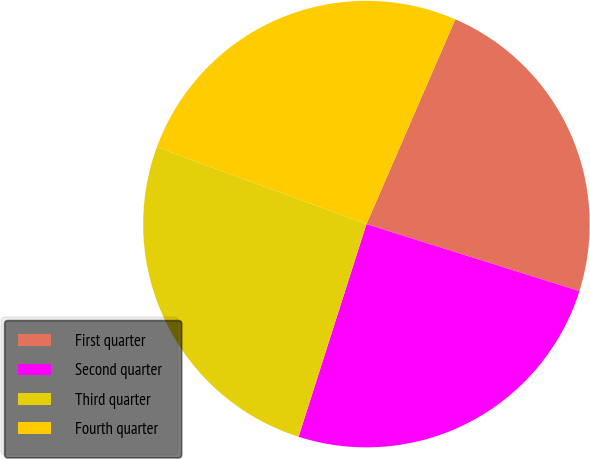Convert chart to OTSL. <chart><loc_0><loc_0><loc_500><loc_500><pie_chart><fcel>First quarter<fcel>Second quarter<fcel>Third quarter<fcel>Fourth quarter<nl><fcel>23.33%<fcel>25.07%<fcel>25.68%<fcel>25.92%<nl></chart> 